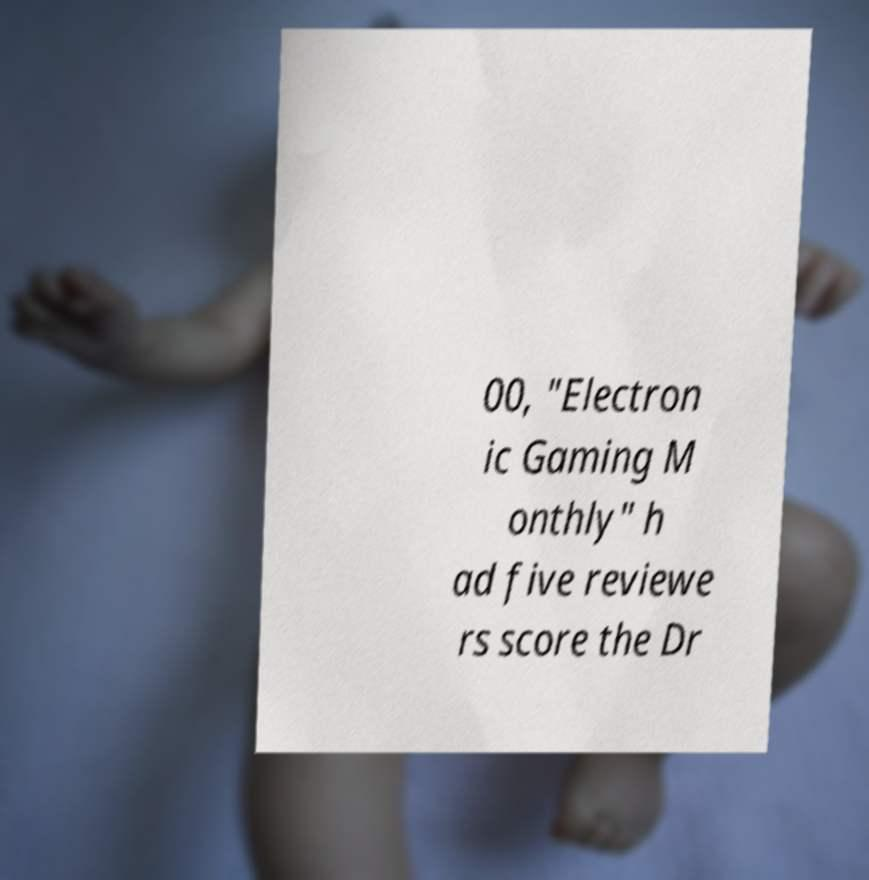Please read and relay the text visible in this image. What does it say? 00, "Electron ic Gaming M onthly" h ad five reviewe rs score the Dr 